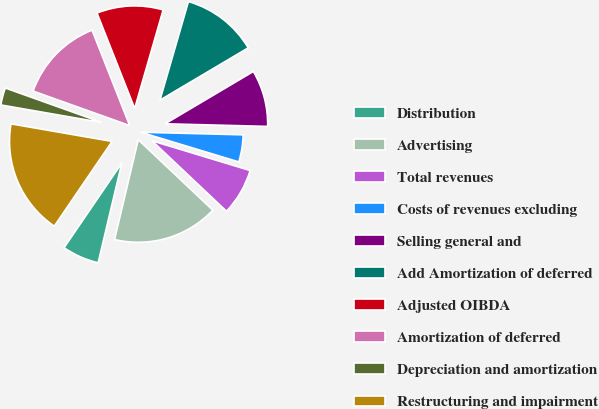Convert chart. <chart><loc_0><loc_0><loc_500><loc_500><pie_chart><fcel>Distribution<fcel>Advertising<fcel>Total revenues<fcel>Costs of revenues excluding<fcel>Selling general and<fcel>Add Amortization of deferred<fcel>Adjusted OIBDA<fcel>Amortization of deferred<fcel>Depreciation and amortization<fcel>Restructuring and impairment<nl><fcel>5.82%<fcel>16.66%<fcel>7.37%<fcel>4.27%<fcel>8.92%<fcel>12.01%<fcel>10.46%<fcel>13.56%<fcel>2.72%<fcel>18.21%<nl></chart> 